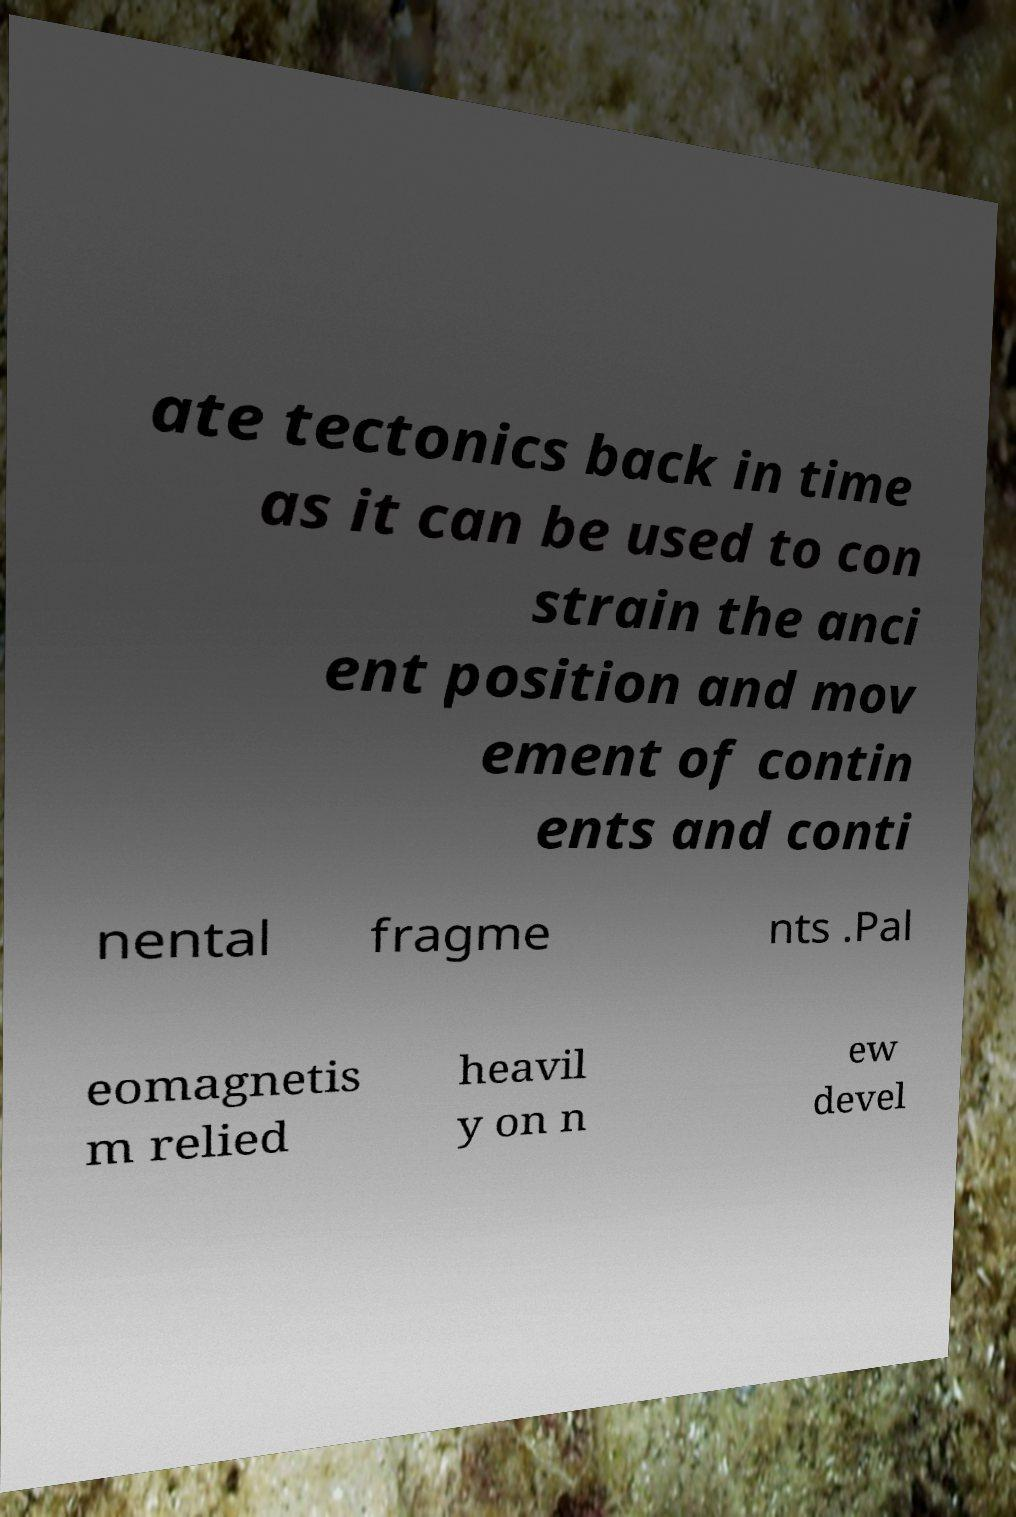Could you assist in decoding the text presented in this image and type it out clearly? ate tectonics back in time as it can be used to con strain the anci ent position and mov ement of contin ents and conti nental fragme nts .Pal eomagnetis m relied heavil y on n ew devel 